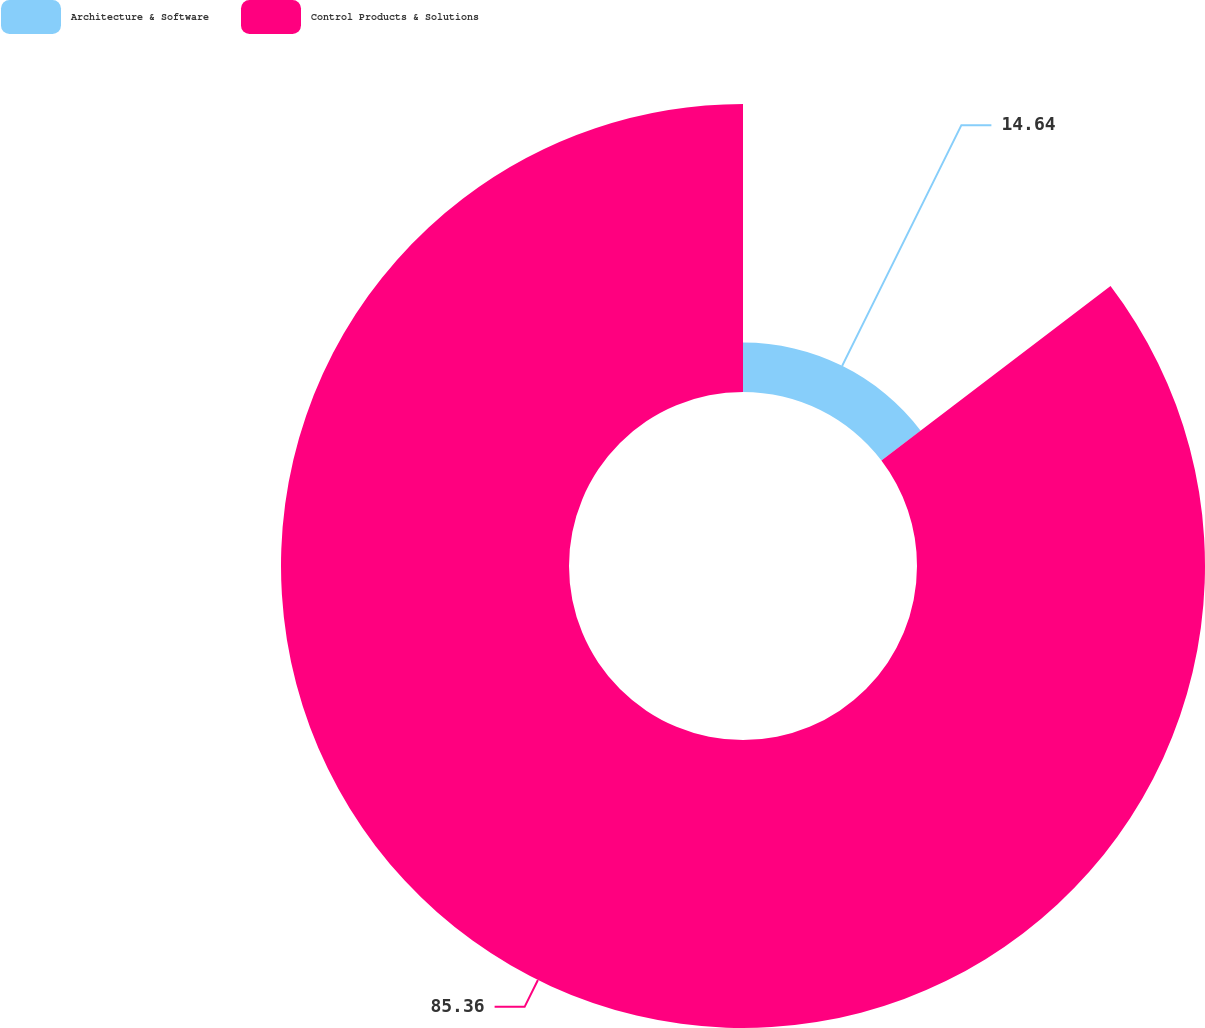Convert chart. <chart><loc_0><loc_0><loc_500><loc_500><pie_chart><fcel>Architecture & Software<fcel>Control Products & Solutions<nl><fcel>14.64%<fcel>85.36%<nl></chart> 